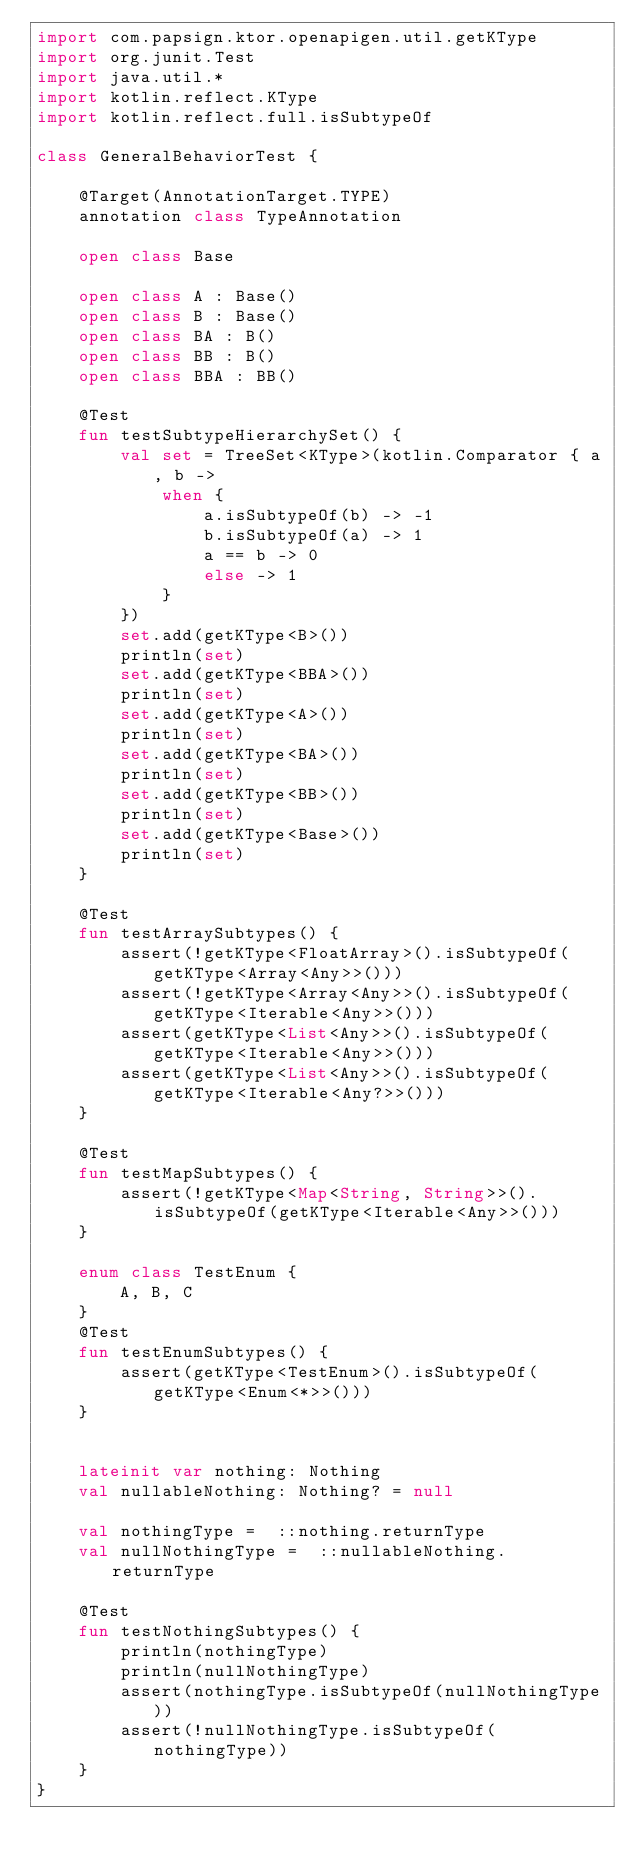Convert code to text. <code><loc_0><loc_0><loc_500><loc_500><_Kotlin_>import com.papsign.ktor.openapigen.util.getKType
import org.junit.Test
import java.util.*
import kotlin.reflect.KType
import kotlin.reflect.full.isSubtypeOf

class GeneralBehaviorTest {

    @Target(AnnotationTarget.TYPE)
    annotation class TypeAnnotation

    open class Base

    open class A : Base()
    open class B : Base()
    open class BA : B()
    open class BB : B()
    open class BBA : BB()

    @Test
    fun testSubtypeHierarchySet() {
        val set = TreeSet<KType>(kotlin.Comparator { a, b ->
            when {
                a.isSubtypeOf(b) -> -1
                b.isSubtypeOf(a) -> 1
                a == b -> 0
                else -> 1
            }
        })
        set.add(getKType<B>())
        println(set)
        set.add(getKType<BBA>())
        println(set)
        set.add(getKType<A>())
        println(set)
        set.add(getKType<BA>())
        println(set)
        set.add(getKType<BB>())
        println(set)
        set.add(getKType<Base>())
        println(set)
    }

    @Test
    fun testArraySubtypes() {
        assert(!getKType<FloatArray>().isSubtypeOf(getKType<Array<Any>>()))
        assert(!getKType<Array<Any>>().isSubtypeOf(getKType<Iterable<Any>>()))
        assert(getKType<List<Any>>().isSubtypeOf(getKType<Iterable<Any>>()))
        assert(getKType<List<Any>>().isSubtypeOf(getKType<Iterable<Any?>>()))
    }

    @Test
    fun testMapSubtypes() {
        assert(!getKType<Map<String, String>>().isSubtypeOf(getKType<Iterable<Any>>()))
    }

    enum class TestEnum {
        A, B, C
    }
    @Test
    fun testEnumSubtypes() {
        assert(getKType<TestEnum>().isSubtypeOf(getKType<Enum<*>>()))
    }


    lateinit var nothing: Nothing
    val nullableNothing: Nothing? = null

    val nothingType =  ::nothing.returnType
    val nullNothingType =  ::nullableNothing.returnType

    @Test
    fun testNothingSubtypes() {
        println(nothingType)
        println(nullNothingType)
        assert(nothingType.isSubtypeOf(nullNothingType))
        assert(!nullNothingType.isSubtypeOf(nothingType))
    }
}
</code> 